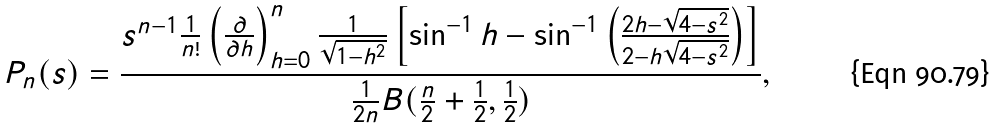<formula> <loc_0><loc_0><loc_500><loc_500>P _ { n } ( s ) = \frac { s ^ { n - 1 } \frac { 1 } { n ! } \left ( \frac { \partial } { \partial h } \right ) ^ { n } _ { h = 0 } \frac { 1 } { \sqrt { 1 - h ^ { 2 } } } \left [ \sin ^ { - 1 } h - \sin ^ { - 1 } \left ( \frac { 2 h - \sqrt { 4 - s ^ { 2 } } } { 2 - h \sqrt { 4 - s ^ { 2 } } } \right ) \right ] } { \frac { 1 } { 2 n } B ( \frac { n } { 2 } + \frac { 1 } { 2 } , \frac { 1 } { 2 } ) } ,</formula> 